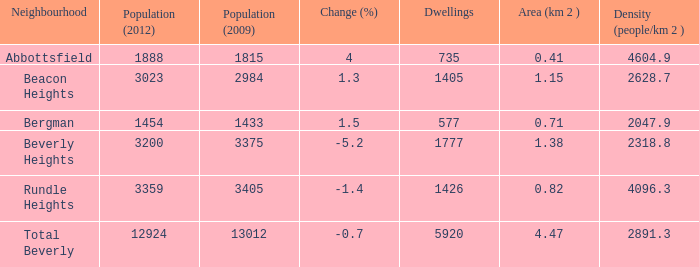How many homes in beverly heights possess a change percent exceeding -5.2? None. 